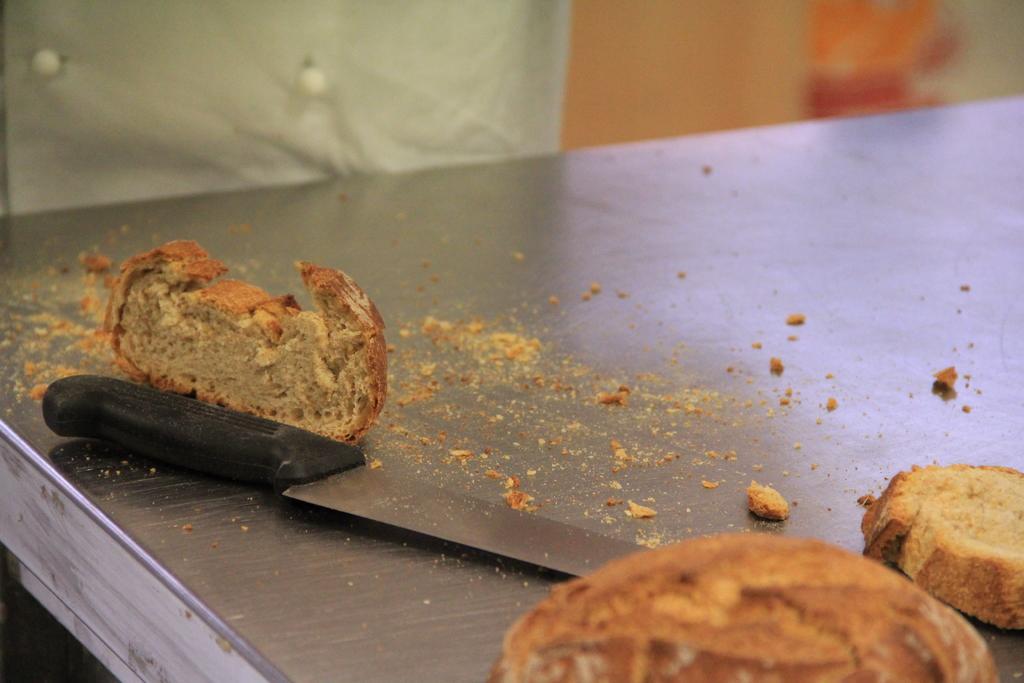How would you summarize this image in a sentence or two? In the center of the image there is a table and we can see breads and a knife placed on the table. In the background we can see a cloth and a wall. 